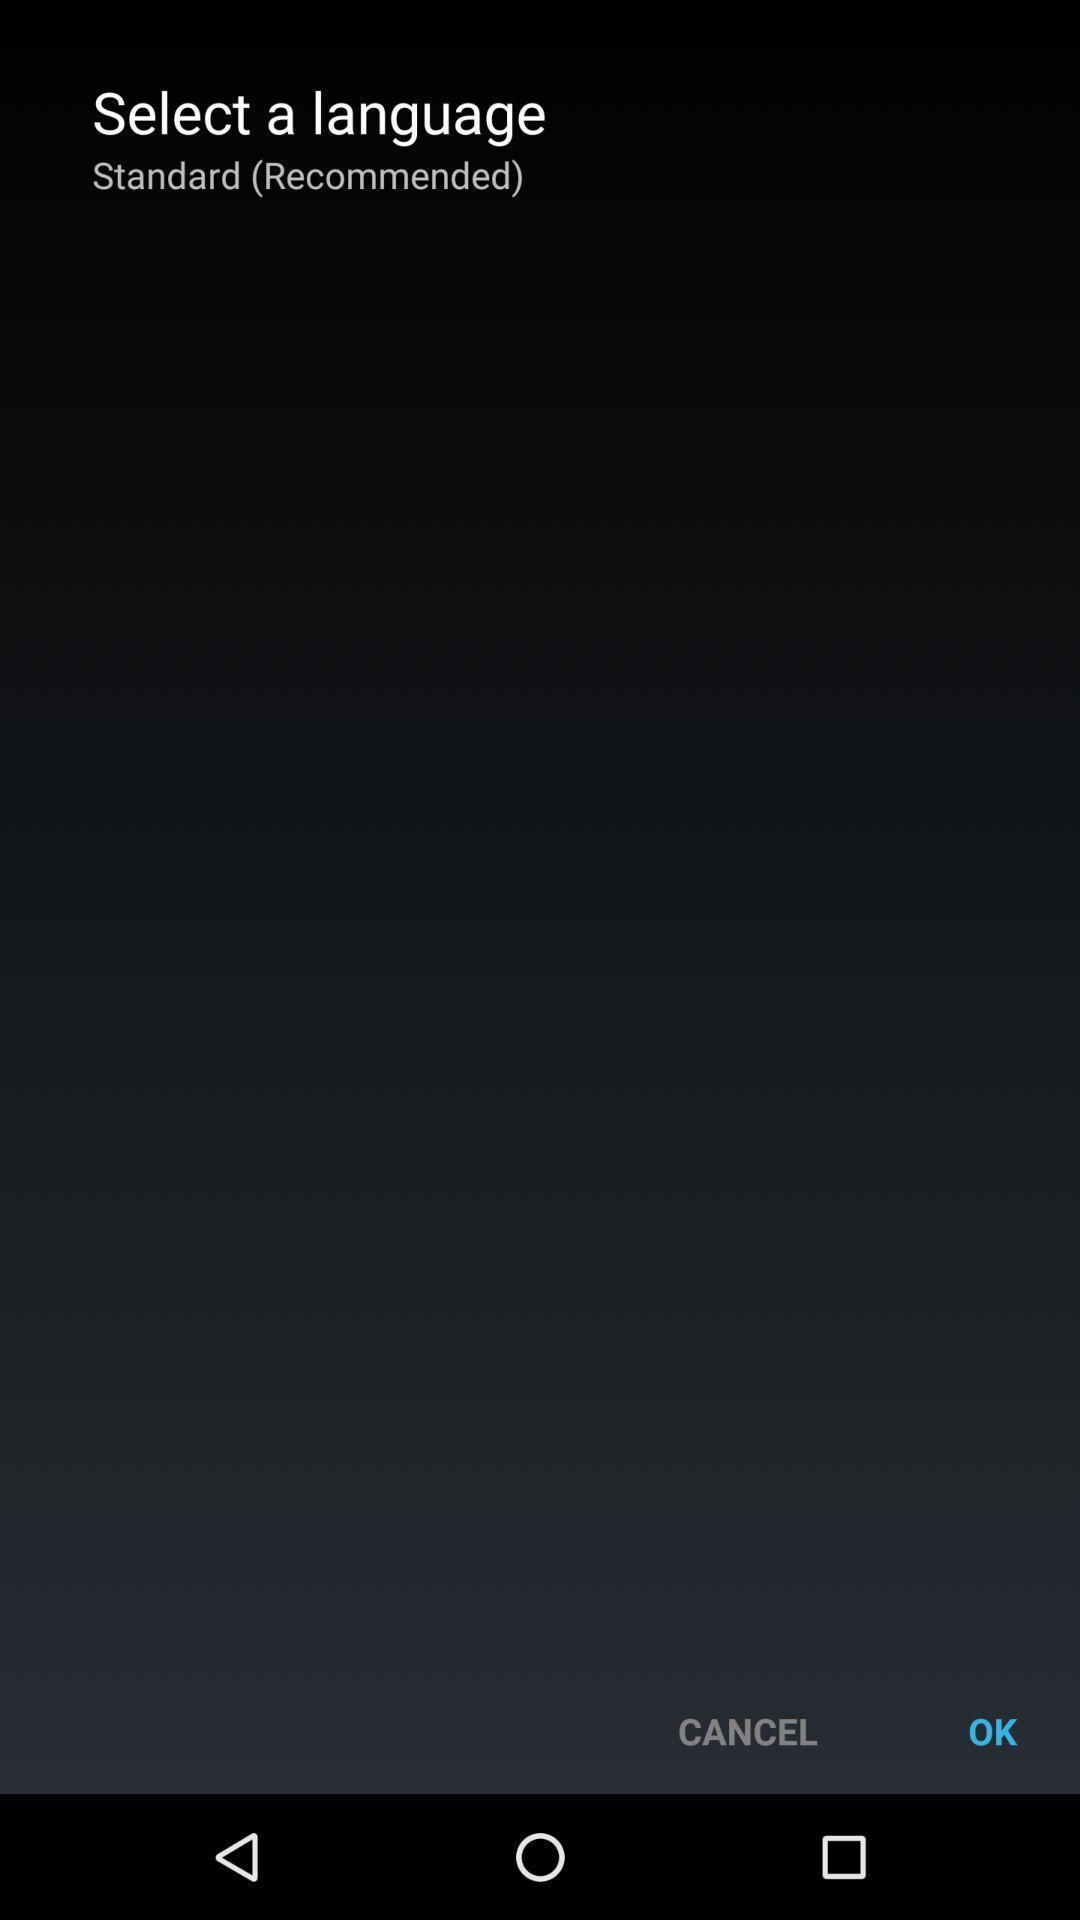What can you discern from this picture? Page showing option like ok. 